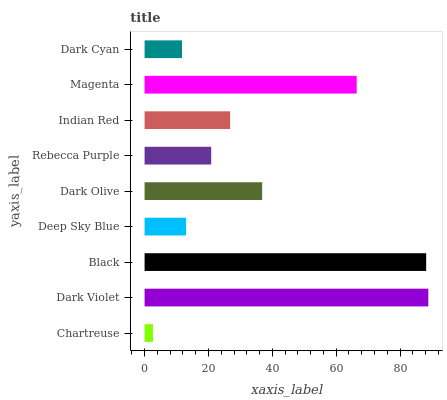Is Chartreuse the minimum?
Answer yes or no. Yes. Is Dark Violet the maximum?
Answer yes or no. Yes. Is Black the minimum?
Answer yes or no. No. Is Black the maximum?
Answer yes or no. No. Is Dark Violet greater than Black?
Answer yes or no. Yes. Is Black less than Dark Violet?
Answer yes or no. Yes. Is Black greater than Dark Violet?
Answer yes or no. No. Is Dark Violet less than Black?
Answer yes or no. No. Is Indian Red the high median?
Answer yes or no. Yes. Is Indian Red the low median?
Answer yes or no. Yes. Is Magenta the high median?
Answer yes or no. No. Is Dark Cyan the low median?
Answer yes or no. No. 